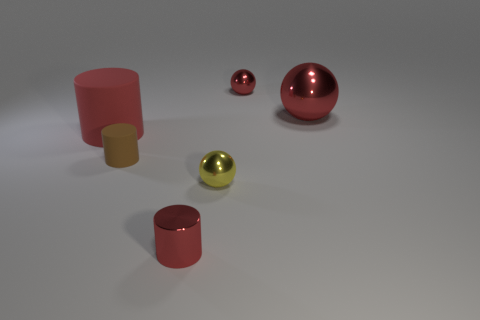Add 1 red cylinders. How many objects exist? 7 Subtract all big red cylinders. How many cylinders are left? 2 Subtract 2 spheres. How many spheres are left? 1 Subtract 0 purple cubes. How many objects are left? 6 Subtract all green cylinders. Subtract all cyan cubes. How many cylinders are left? 3 Subtract all gray spheres. How many red cylinders are left? 2 Subtract all blue matte blocks. Subtract all big cylinders. How many objects are left? 5 Add 6 metallic cylinders. How many metallic cylinders are left? 7 Add 1 tiny red cylinders. How many tiny red cylinders exist? 2 Subtract all yellow spheres. How many spheres are left? 2 